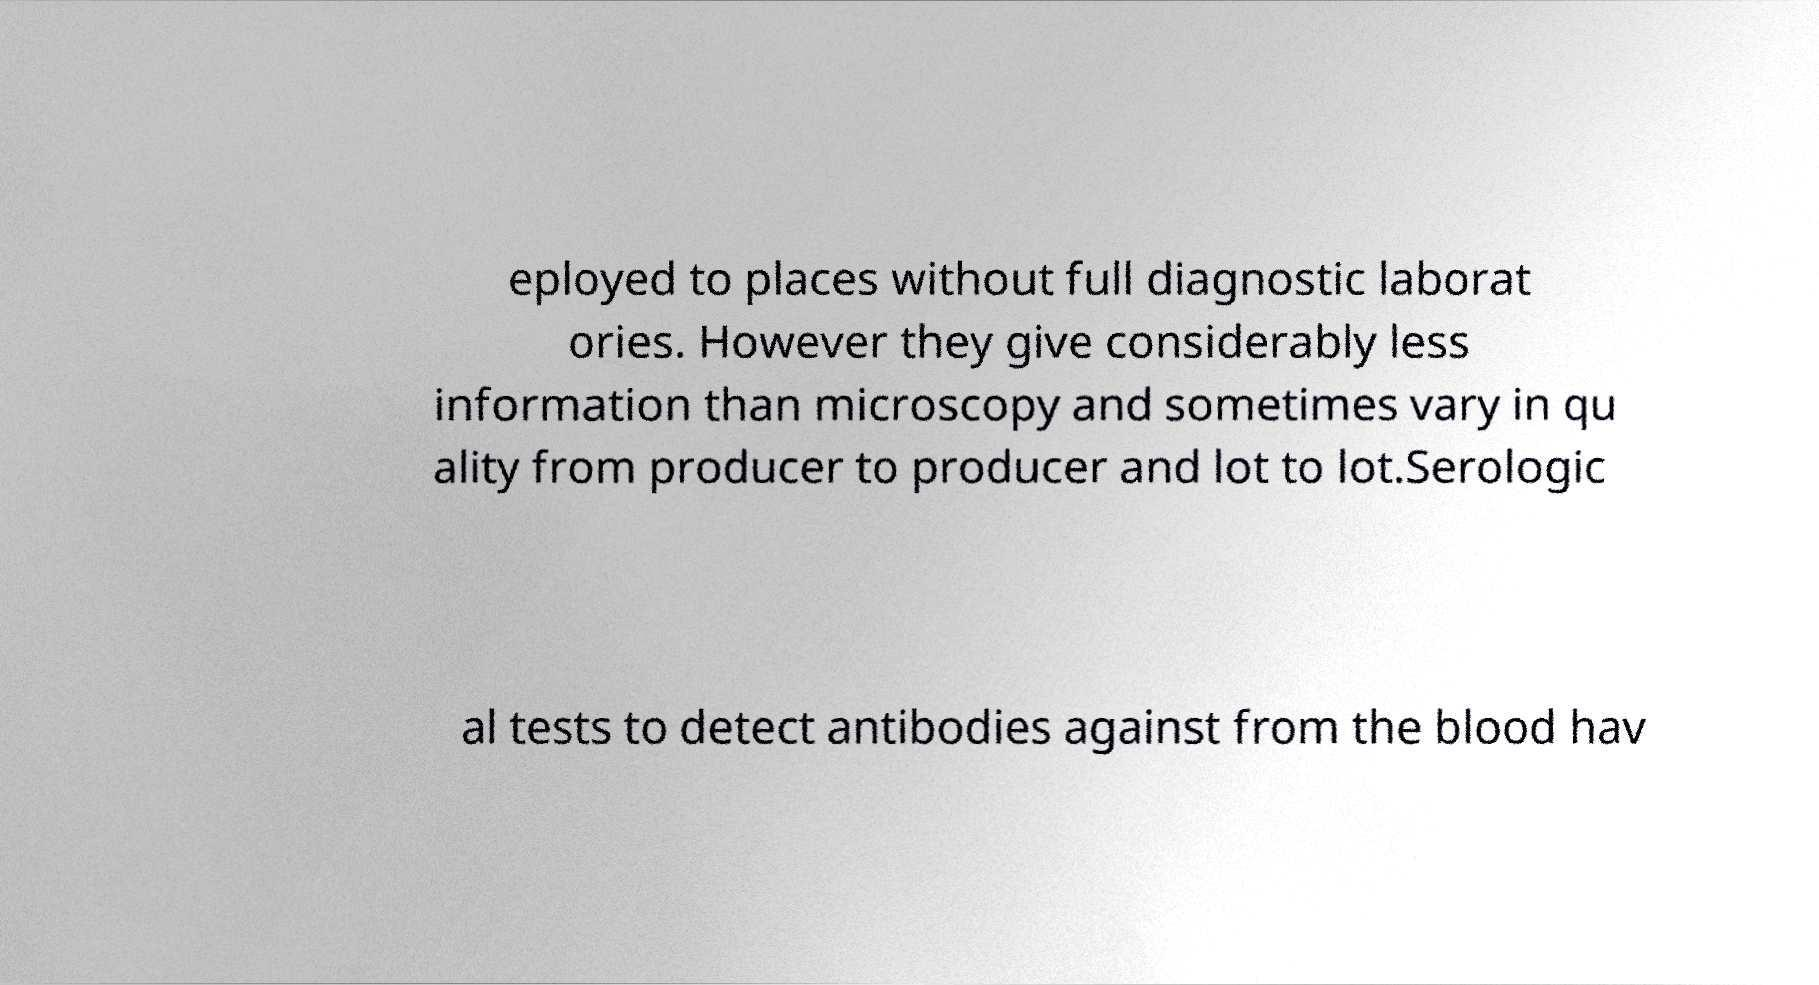Can you accurately transcribe the text from the provided image for me? eployed to places without full diagnostic laborat ories. However they give considerably less information than microscopy and sometimes vary in qu ality from producer to producer and lot to lot.Serologic al tests to detect antibodies against from the blood hav 